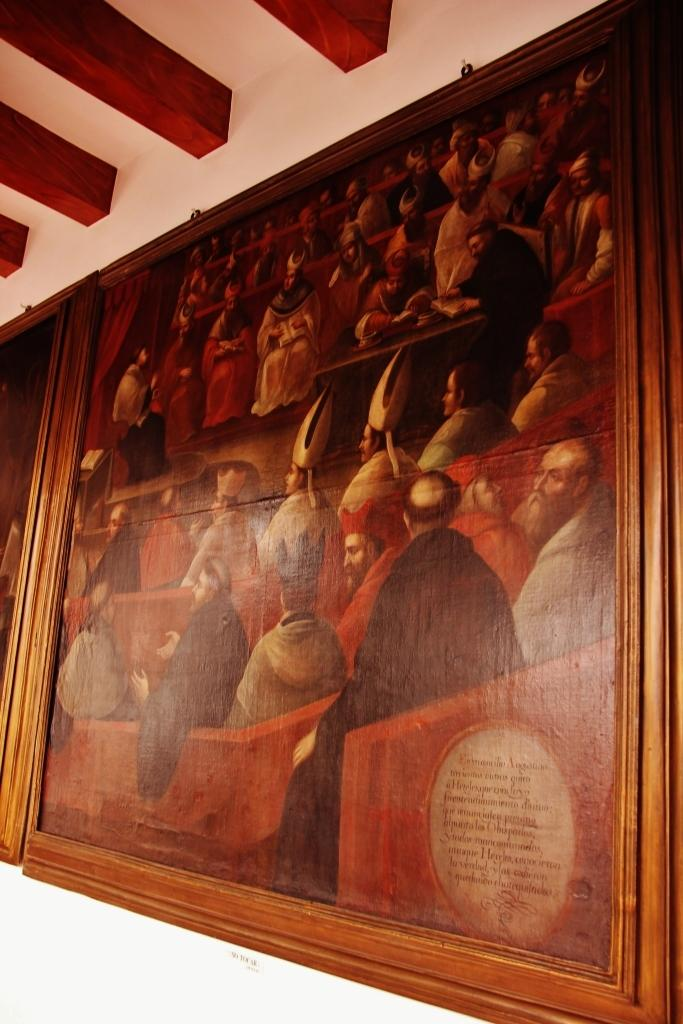What can be seen hanging on the wall in the image? There are photo frames on the wall in the image. What part of a building is visible at the top of the image? The roof is visible at the top of the image. What type of jelly is being used to hold the photo frames on the wall in the image? There is no jelly present in the image; the photo frames are hanging on the wall without any visible adhesive. What kind of grain can be seen growing in the image? There is no grain visible in the image; it only features photo frames on the wall and a roof at the top. 